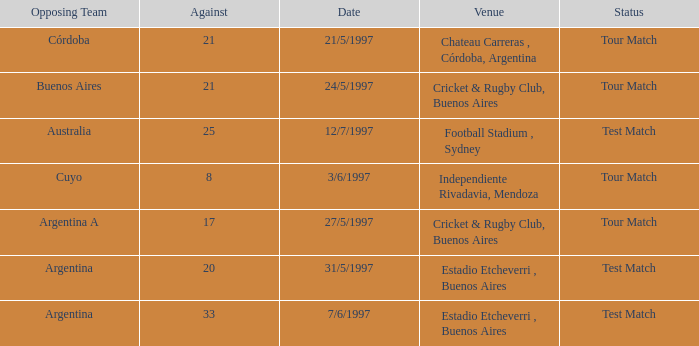Which venue has an against value larger than 21 and had Argentina as an opposing team. Estadio Etcheverri , Buenos Aires. 